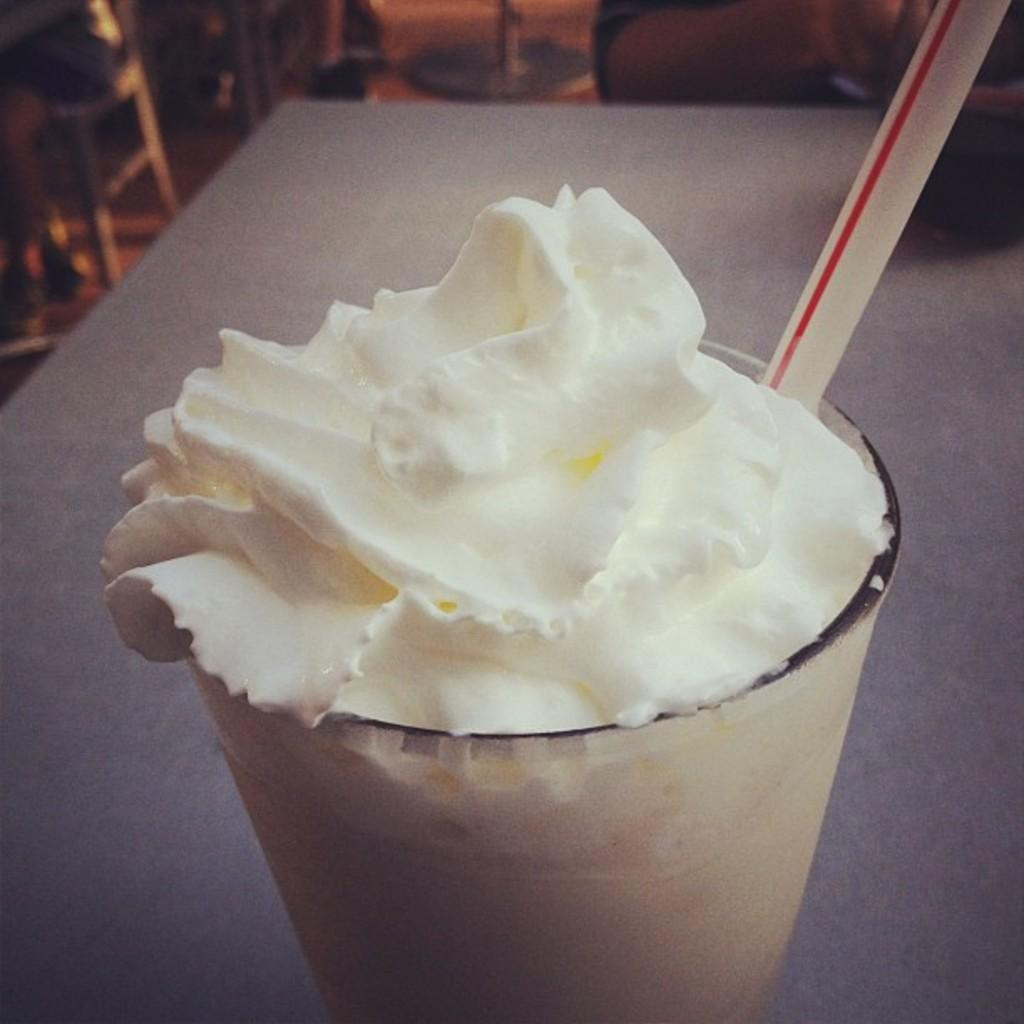What is in the image that is typically used for drinking? There is a straw in the image. What is the straw used for in the image? The straw is used for drinking cream in the image. Where is the cup with the cream and straw located? The cup is on a table. What is the main component of the drink in the image? Cream is the main component of the drink in the image. What type of plants can be seen growing on the elbow in the image? There are no plants or elbows present in the image; it features a cup with cream and a straw on a table. 